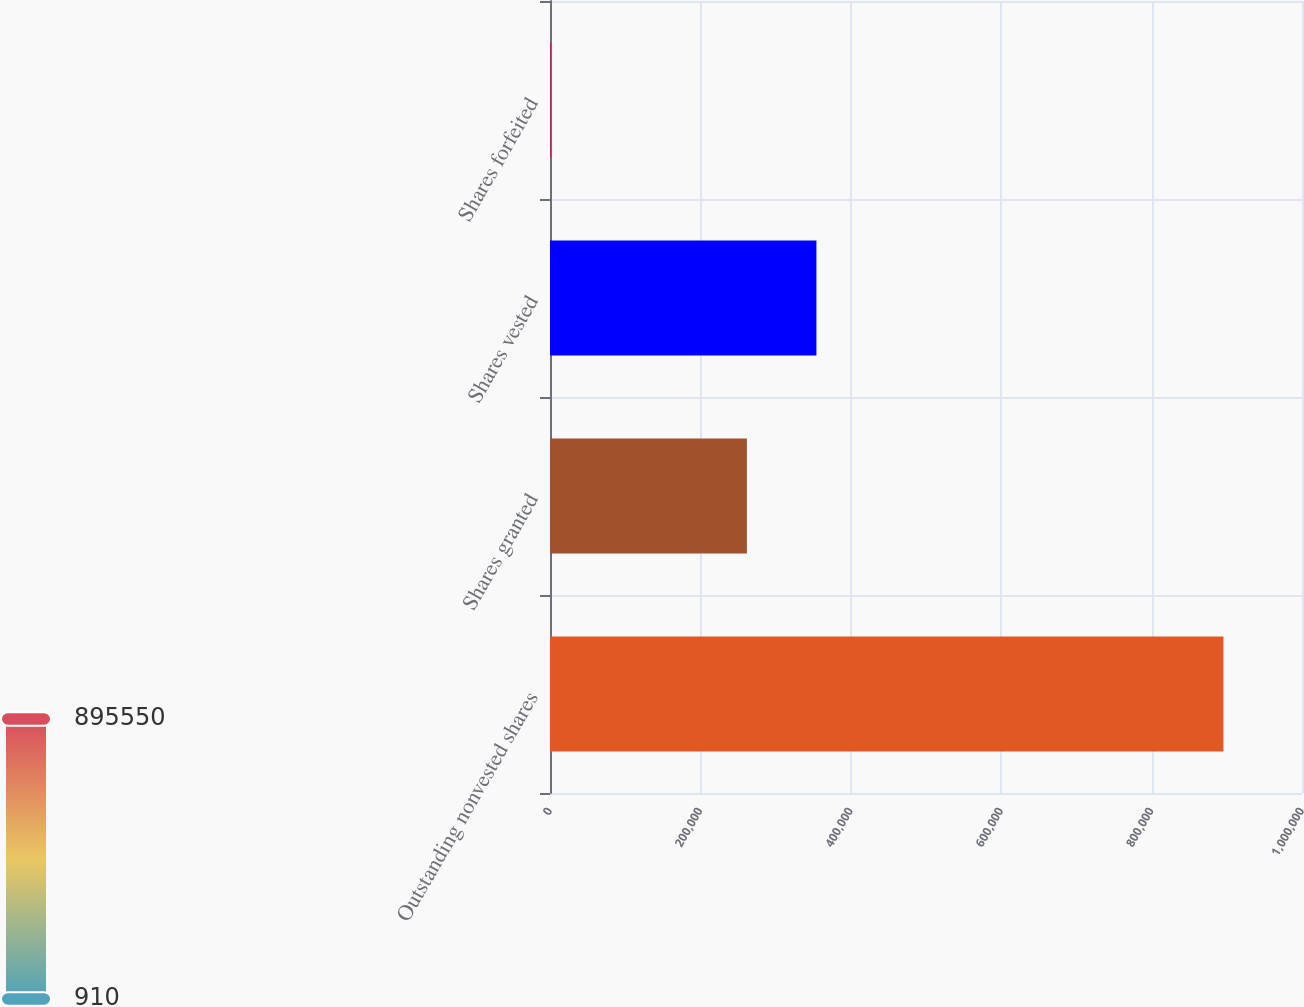Convert chart to OTSL. <chart><loc_0><loc_0><loc_500><loc_500><bar_chart><fcel>Outstanding nonvested shares<fcel>Shares granted<fcel>Shares vested<fcel>Shares forfeited<nl><fcel>895550<fcel>261811<fcel>354273<fcel>910<nl></chart> 